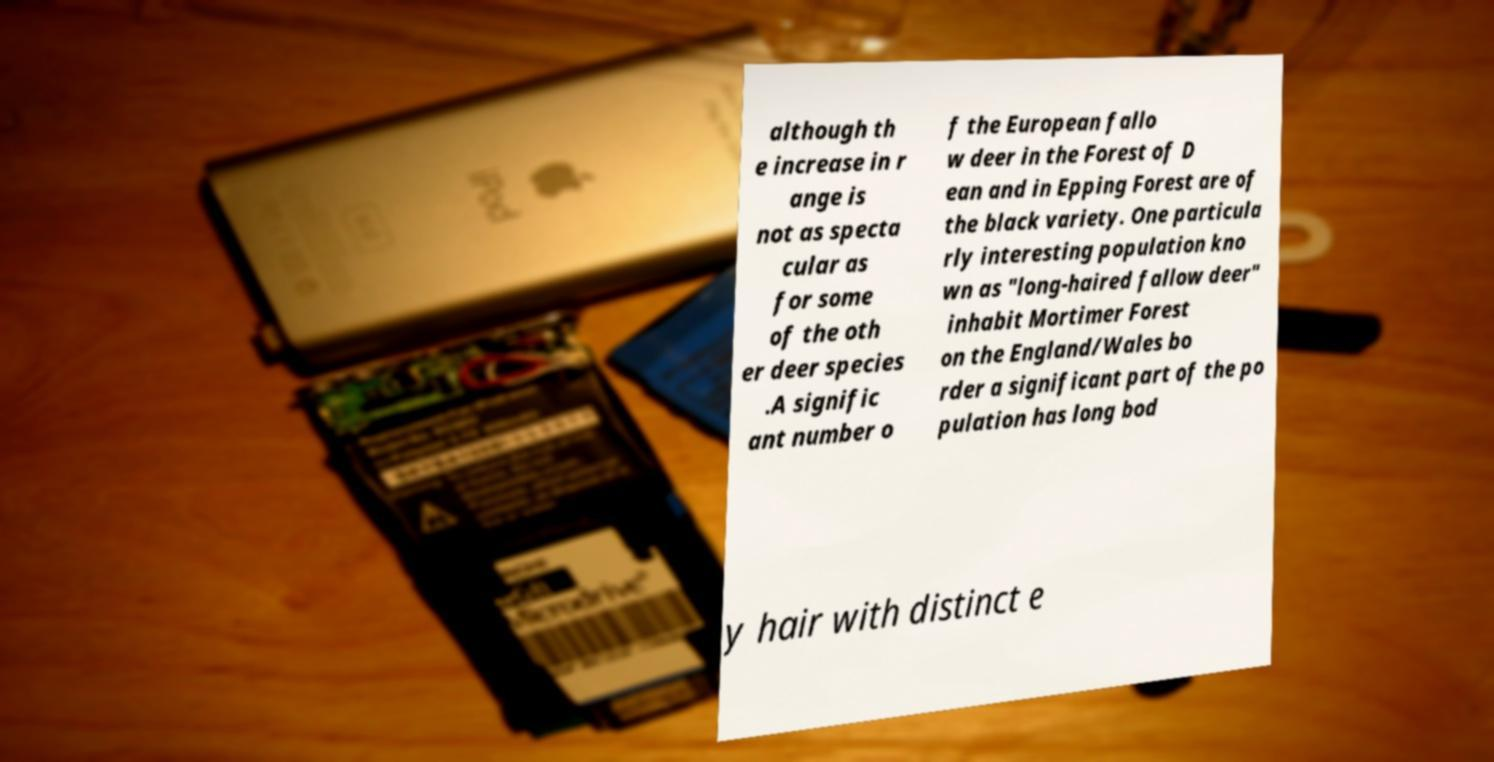What messages or text are displayed in this image? I need them in a readable, typed format. although th e increase in r ange is not as specta cular as for some of the oth er deer species .A signific ant number o f the European fallo w deer in the Forest of D ean and in Epping Forest are of the black variety. One particula rly interesting population kno wn as "long-haired fallow deer" inhabit Mortimer Forest on the England/Wales bo rder a significant part of the po pulation has long bod y hair with distinct e 